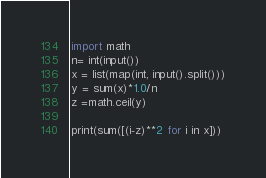Convert code to text. <code><loc_0><loc_0><loc_500><loc_500><_Python_>import math
n= int(input()) 
x = list(map(int, input().split()))
y = sum(x)*1.0/n
z =math.ceil(y)

print(sum([(i-z)**2 for i in x]))
</code> 